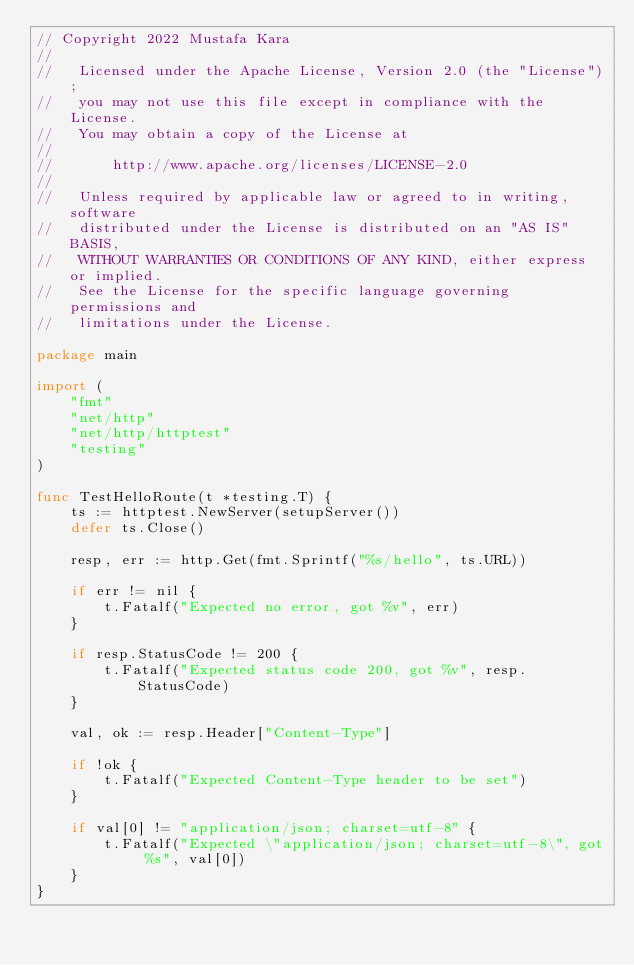Convert code to text. <code><loc_0><loc_0><loc_500><loc_500><_Go_>// Copyright 2022 Mustafa Kara
//
//   Licensed under the Apache License, Version 2.0 (the "License");
//   you may not use this file except in compliance with the License.
//   You may obtain a copy of the License at
//
//       http://www.apache.org/licenses/LICENSE-2.0
//
//   Unless required by applicable law or agreed to in writing, software
//   distributed under the License is distributed on an "AS IS" BASIS,
//   WITHOUT WARRANTIES OR CONDITIONS OF ANY KIND, either express or implied.
//   See the License for the specific language governing permissions and
//   limitations under the License.

package main

import (
	"fmt"
	"net/http"
	"net/http/httptest"
	"testing"
)

func TestHelloRoute(t *testing.T) {
	ts := httptest.NewServer(setupServer())
	defer ts.Close()

	resp, err := http.Get(fmt.Sprintf("%s/hello", ts.URL))

	if err != nil {
		t.Fatalf("Expected no error, got %v", err)
	}

	if resp.StatusCode != 200 {
		t.Fatalf("Expected status code 200, got %v", resp.StatusCode)
	}

	val, ok := resp.Header["Content-Type"]

	if !ok {
		t.Fatalf("Expected Content-Type header to be set")
	}

	if val[0] != "application/json; charset=utf-8" {
		t.Fatalf("Expected \"application/json; charset=utf-8\", got %s", val[0])
	}
}
</code> 